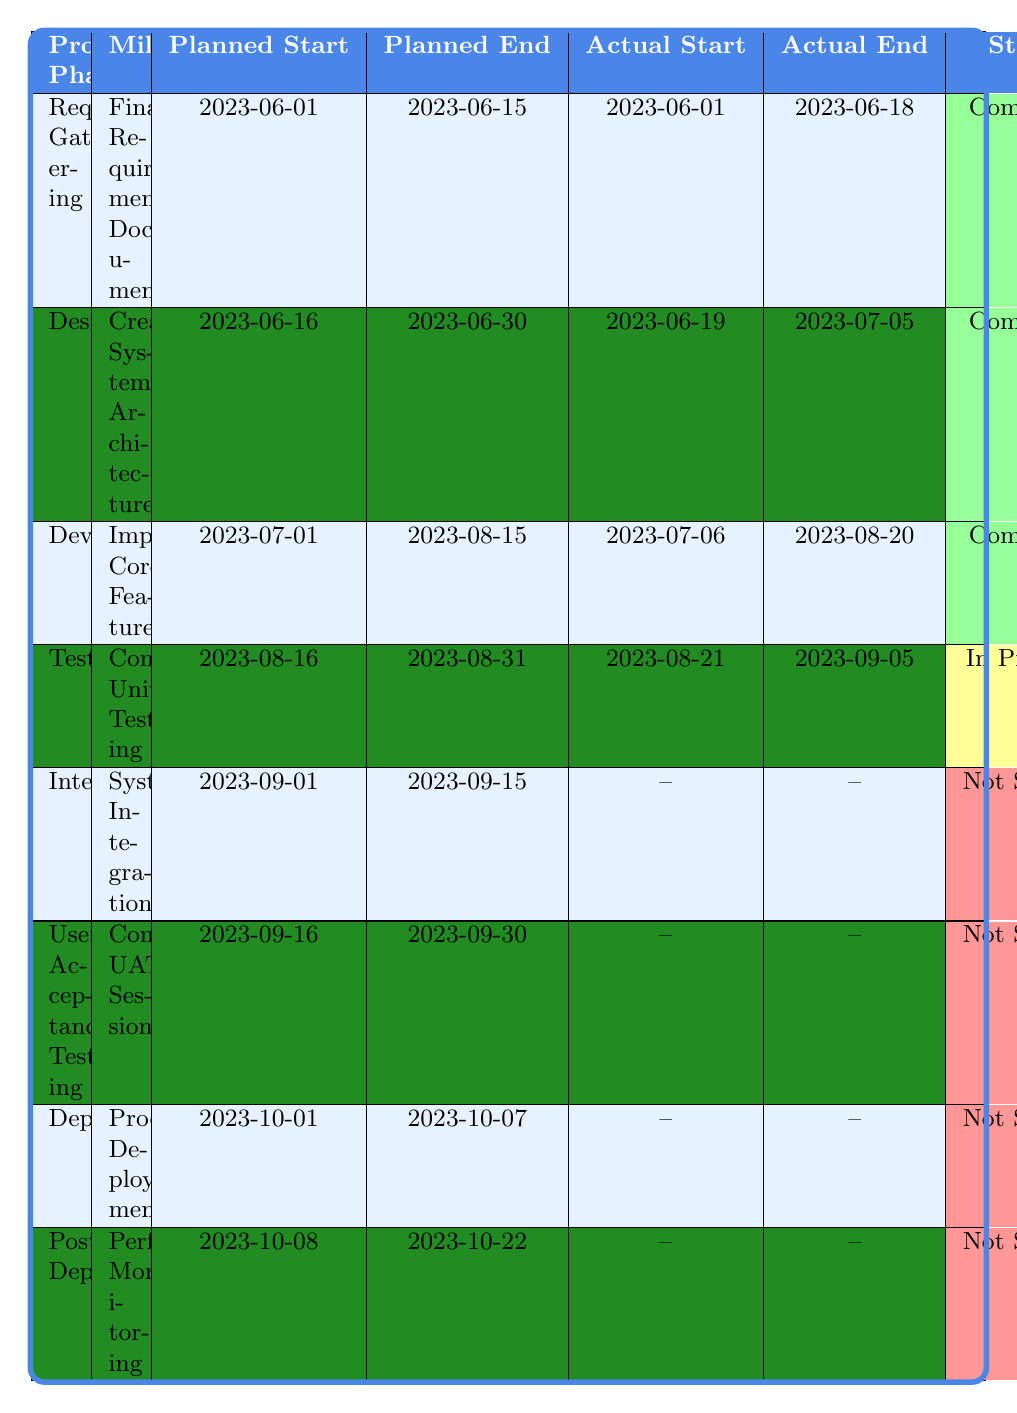What is the status of the "Complete Unit Testing" milestone? The table shows that the "Complete Unit Testing" milestone is currently marked as "In Progress".
Answer: In Progress Which team is assigned to conduct User Acceptance Testing? According to the table, the team assigned to conduct User Acceptance Testing is the QA Team.
Answer: QA Team What is the risk level of the "System Integration" milestone? The table indicates that the "System Integration" milestone has a risk level categorized as High.
Answer: High How many milestones are completed? By counting the entries under the "Status" column marked as "Completed", we find that there are three completed milestones: Finalize Requirements Document, Create System Architecture, and Implement Core Features.
Answer: 3 What is the planned end date for the "Production Deployment" milestone? The table lists the planned end date for the "Production Deployment" milestone as 2023-10-07.
Answer: 2023-10-07 Which project phase is assigned to the Development Team? The table shows that the Development Team is assigned to the "Development" phase, specifically for the milestone "Implement Core Features".
Answer: Development If the "Complete Unit Testing" milestone finishes on time, what is the next milestone to begin? Following the milestones in order, if "Complete Unit Testing" finishes, the next milestone is "System Integration" which is scheduled to begin on 2023-09-01.
Answer: System Integration What is the average risk level of the milestones that are "Not Started"? The milestones that are "Not Started" include System Integration, Conduct UAT Sessions, Production Deployment, and Performance Monitoring. Their risk levels are High, Medium, High, and Low respectively. To find the average, we assign numerical values: High = 3, Medium = 2, Low = 1. The sum is (3 + 2 + 3 + 1) = 9 and there are 4 milestones, so the average risk level is 9/4 = 2.25 which translates to Medium.
Answer: Medium Was the "Implement Core Features" milestone completed before its planned end date? The "Planned End Date" for the "Implement Core Features" milestone is 2023-08-15, but its "Actual End Date" is 2023-08-20, indicating it was completed after its planned end date.
Answer: No What project phase has the highest risk level among its milestones? The Development phase has the milestone "Implement Core Features" with a High risk level, and the Integration phase also has a milestone "System Integration" that is marked as High. However, the Development phase has one completed milestone, while Integration has not started. Therefore, Development has the highest risk level associated with an actual completed milestone.
Answer: Development 